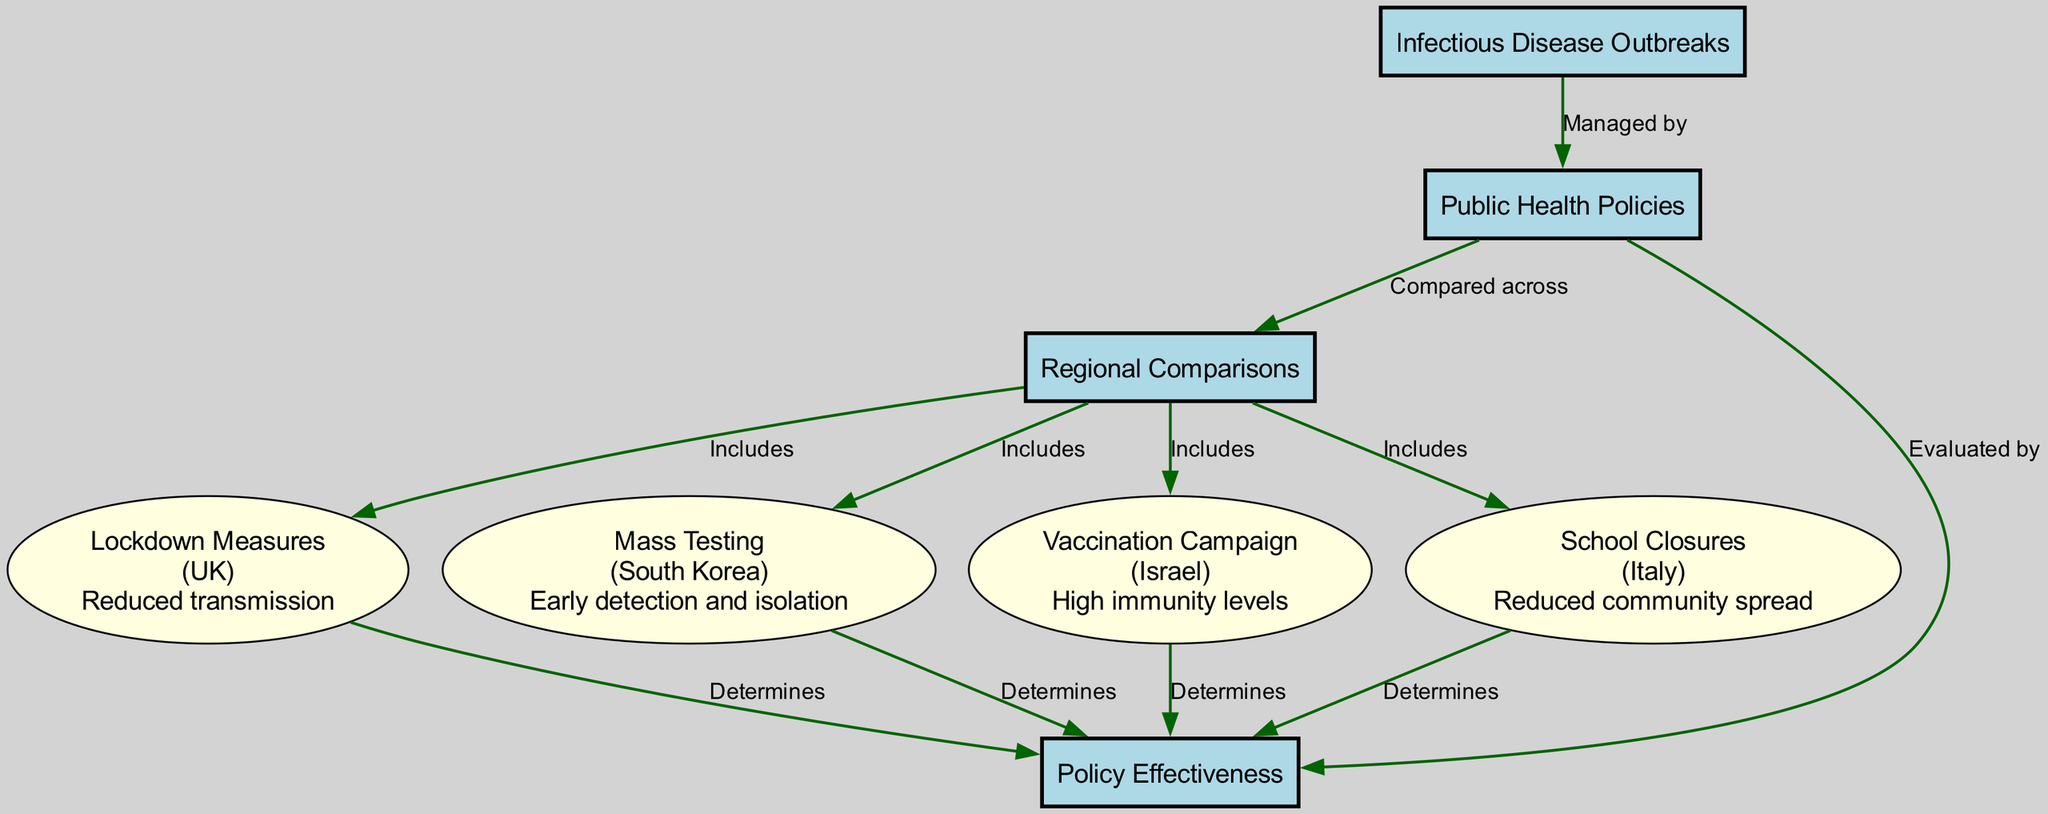What is the total number of nodes in the diagram? The diagram contains a total of 8 nodes, including categories and policies. Each node represents a key aspect of the study such as infectious disease outbreaks, public health policies, regional comparisons, policy effectiveness, and specific policies from different regions.
Answer: 8 What type of relationship exists between 'Infectious Disease Outbreaks' and 'Public Health Policies'? The relationship is labeled as "Managed by," indicating that public health policies are actions taken to control infectious disease outbreaks. This shows a direct dependency where policies are created in response to outbreaks.
Answer: Managed by Which region is associated with the 'Lockdown Measures' policy? The 'Lockdown Measures' policy is associated with the UK region, as indicated in the properties of the node. Each policy node specifies the region it applies to, and this one is outlined as being relevant to the UK.
Answer: UK What are the outcomes of the 'Mass Testing' policy? The outcome of the 'Mass Testing' policy is "Early detection and isolation," which is directly specified in the properties of the policy node related to South Korea. It highlights the effectiveness of mass testing in managing outbreaks.
Answer: Early detection and isolation How many policy nodes are included in the diagram? The diagram includes four policy nodes, which consist of Lockdown Measures, Mass Testing, Vaccination Campaign, and School Closures. Each policy node contributes directly to assessing public health policy effectiveness.
Answer: 4 Which policy was implemented in Italy, and what was its effect? The policy implemented in Italy is 'School Closures,' and its effect was "Reduced community spread." This is detailed in the properties of the node representing the policy, indicating its intended outcome.
Answer: Reduced community spread What do all policy nodes determine according to the diagram? All policy nodes determine 'Policy Effectiveness,' indicating that each specific policy's impact is evaluated based on how effectively it controls infectious disease outbreaks. This is shown by the connections leading from each policy node to the category node for Policy Effectiveness.
Answer: Policy Effectiveness Which region's public health policy is focused on achieving high immunity levels? The public health policy focused on achieving high immunity levels is associated with the region of Israel, specifically through the 'Vaccination Campaign' node. The properties of this policy node explicitly mention its relationship to Israel's vaccination efforts.
Answer: Israel 